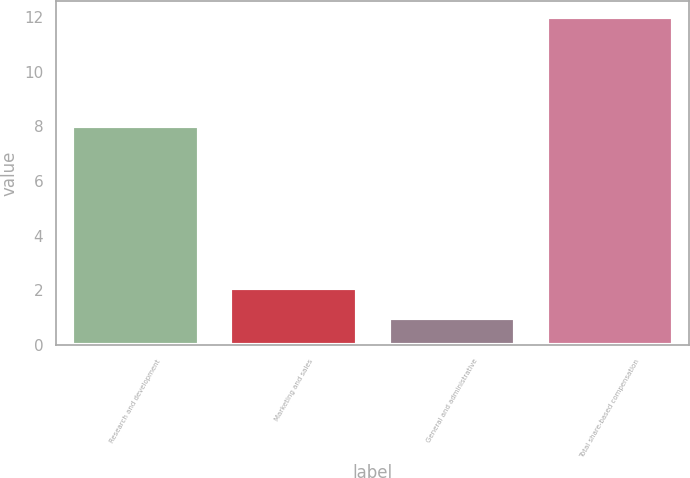Convert chart to OTSL. <chart><loc_0><loc_0><loc_500><loc_500><bar_chart><fcel>Research and development<fcel>Marketing and sales<fcel>General and administrative<fcel>Total share-based compensation<nl><fcel>8<fcel>2.1<fcel>1<fcel>12<nl></chart> 